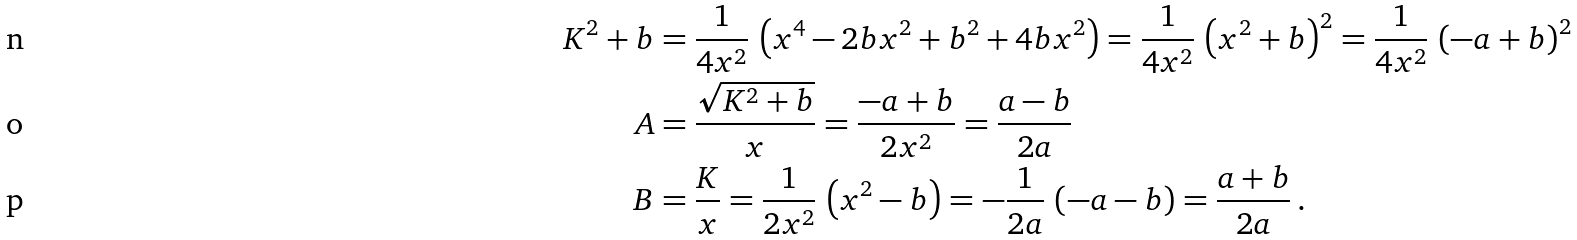Convert formula to latex. <formula><loc_0><loc_0><loc_500><loc_500>K ^ { 2 } + b & = \frac { 1 } { 4 x ^ { 2 } } \, \left ( x ^ { 4 } - 2 b x ^ { 2 } + b ^ { 2 } + 4 b x ^ { 2 } \right ) = \frac { 1 } { 4 x ^ { 2 } } \, \left ( x ^ { 2 } + b \right ) ^ { 2 } = \frac { 1 } { 4 x ^ { 2 } } \, \left ( - a + b \right ) ^ { 2 } \\ A & = \frac { \sqrt { K ^ { 2 } + b } } { x } = \frac { - a + b } { 2 x ^ { 2 } } = \frac { a - b } { 2 a } \\ B & = \frac { K } { x } = \frac { 1 } { 2 x ^ { 2 } } \, \left ( x ^ { 2 } - b \right ) = - \frac { 1 } { 2 a } \, \left ( - a - b \right ) = \frac { a + b } { 2 a } \, .</formula> 